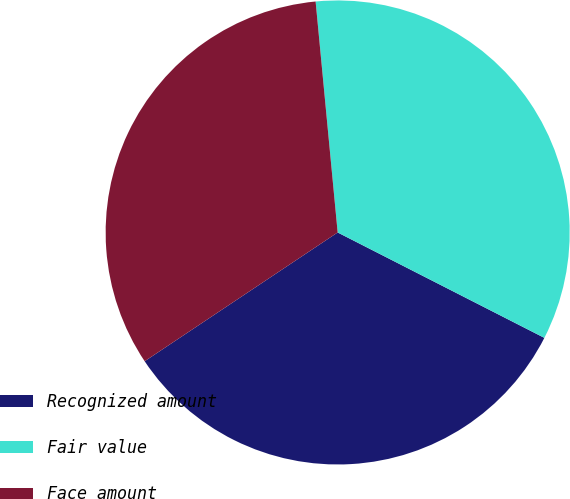Convert chart. <chart><loc_0><loc_0><loc_500><loc_500><pie_chart><fcel>Recognized amount<fcel>Fair value<fcel>Face amount<nl><fcel>33.13%<fcel>34.02%<fcel>32.85%<nl></chart> 